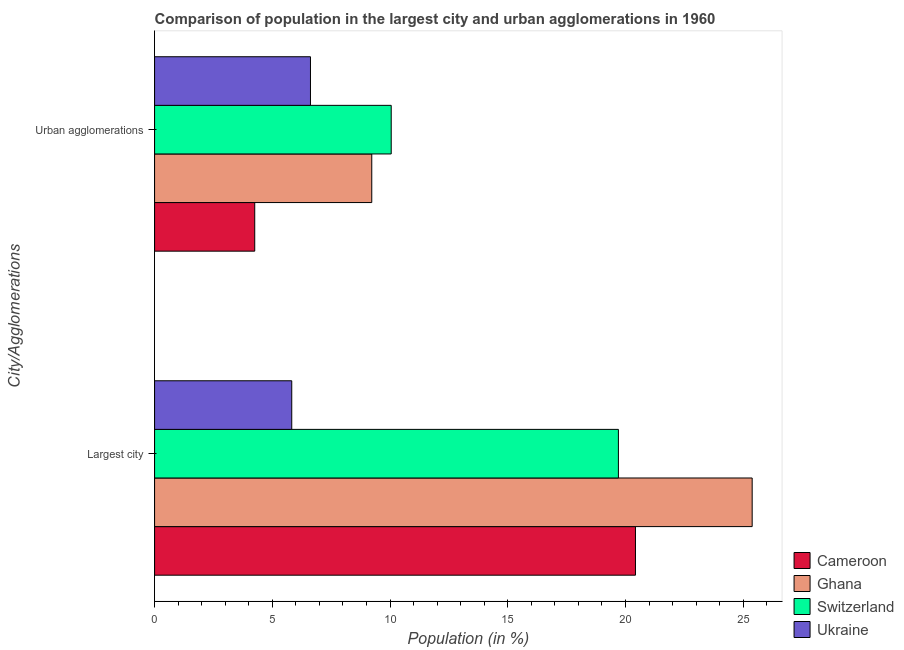How many groups of bars are there?
Make the answer very short. 2. Are the number of bars on each tick of the Y-axis equal?
Keep it short and to the point. Yes. What is the label of the 1st group of bars from the top?
Offer a terse response. Urban agglomerations. What is the population in the largest city in Cameroon?
Provide a succinct answer. 20.42. Across all countries, what is the maximum population in the largest city?
Keep it short and to the point. 25.38. Across all countries, what is the minimum population in the largest city?
Give a very brief answer. 5.83. In which country was the population in urban agglomerations maximum?
Provide a succinct answer. Switzerland. In which country was the population in the largest city minimum?
Give a very brief answer. Ukraine. What is the total population in the largest city in the graph?
Provide a succinct answer. 71.33. What is the difference between the population in the largest city in Ghana and that in Switzerland?
Offer a terse response. 5.68. What is the difference between the population in the largest city in Switzerland and the population in urban agglomerations in Cameroon?
Keep it short and to the point. 15.45. What is the average population in the largest city per country?
Make the answer very short. 17.83. What is the difference between the population in urban agglomerations and population in the largest city in Ghana?
Offer a very short reply. -16.16. In how many countries, is the population in the largest city greater than 7 %?
Offer a terse response. 3. What is the ratio of the population in urban agglomerations in Ukraine to that in Ghana?
Your answer should be very brief. 0.72. What does the 2nd bar from the top in Largest city represents?
Your answer should be compact. Switzerland. What does the 3rd bar from the bottom in Urban agglomerations represents?
Offer a very short reply. Switzerland. How many bars are there?
Your response must be concise. 8. Are all the bars in the graph horizontal?
Your answer should be compact. Yes. What is the difference between two consecutive major ticks on the X-axis?
Provide a succinct answer. 5. Are the values on the major ticks of X-axis written in scientific E-notation?
Give a very brief answer. No. Does the graph contain any zero values?
Ensure brevity in your answer.  No. Does the graph contain grids?
Your response must be concise. No. How many legend labels are there?
Give a very brief answer. 4. How are the legend labels stacked?
Make the answer very short. Vertical. What is the title of the graph?
Make the answer very short. Comparison of population in the largest city and urban agglomerations in 1960. Does "El Salvador" appear as one of the legend labels in the graph?
Your answer should be very brief. No. What is the label or title of the Y-axis?
Provide a short and direct response. City/Agglomerations. What is the Population (in %) in Cameroon in Largest city?
Your answer should be very brief. 20.42. What is the Population (in %) in Ghana in Largest city?
Provide a short and direct response. 25.38. What is the Population (in %) in Switzerland in Largest city?
Your response must be concise. 19.7. What is the Population (in %) of Ukraine in Largest city?
Give a very brief answer. 5.83. What is the Population (in %) in Cameroon in Urban agglomerations?
Your answer should be compact. 4.25. What is the Population (in %) in Ghana in Urban agglomerations?
Your answer should be compact. 9.22. What is the Population (in %) in Switzerland in Urban agglomerations?
Your answer should be very brief. 10.05. What is the Population (in %) in Ukraine in Urban agglomerations?
Offer a terse response. 6.62. Across all City/Agglomerations, what is the maximum Population (in %) of Cameroon?
Your response must be concise. 20.42. Across all City/Agglomerations, what is the maximum Population (in %) in Ghana?
Provide a succinct answer. 25.38. Across all City/Agglomerations, what is the maximum Population (in %) in Switzerland?
Ensure brevity in your answer.  19.7. Across all City/Agglomerations, what is the maximum Population (in %) in Ukraine?
Your answer should be very brief. 6.62. Across all City/Agglomerations, what is the minimum Population (in %) in Cameroon?
Keep it short and to the point. 4.25. Across all City/Agglomerations, what is the minimum Population (in %) in Ghana?
Your response must be concise. 9.22. Across all City/Agglomerations, what is the minimum Population (in %) of Switzerland?
Your response must be concise. 10.05. Across all City/Agglomerations, what is the minimum Population (in %) of Ukraine?
Your response must be concise. 5.83. What is the total Population (in %) of Cameroon in the graph?
Keep it short and to the point. 24.68. What is the total Population (in %) of Ghana in the graph?
Your response must be concise. 34.6. What is the total Population (in %) in Switzerland in the graph?
Offer a very short reply. 29.75. What is the total Population (in %) in Ukraine in the graph?
Your response must be concise. 12.45. What is the difference between the Population (in %) in Cameroon in Largest city and that in Urban agglomerations?
Provide a succinct answer. 16.17. What is the difference between the Population (in %) in Ghana in Largest city and that in Urban agglomerations?
Ensure brevity in your answer.  16.16. What is the difference between the Population (in %) of Switzerland in Largest city and that in Urban agglomerations?
Your answer should be compact. 9.65. What is the difference between the Population (in %) in Ukraine in Largest city and that in Urban agglomerations?
Make the answer very short. -0.79. What is the difference between the Population (in %) in Cameroon in Largest city and the Population (in %) in Ghana in Urban agglomerations?
Provide a succinct answer. 11.2. What is the difference between the Population (in %) in Cameroon in Largest city and the Population (in %) in Switzerland in Urban agglomerations?
Your response must be concise. 10.37. What is the difference between the Population (in %) in Cameroon in Largest city and the Population (in %) in Ukraine in Urban agglomerations?
Give a very brief answer. 13.8. What is the difference between the Population (in %) in Ghana in Largest city and the Population (in %) in Switzerland in Urban agglomerations?
Your response must be concise. 15.33. What is the difference between the Population (in %) of Ghana in Largest city and the Population (in %) of Ukraine in Urban agglomerations?
Offer a terse response. 18.76. What is the difference between the Population (in %) of Switzerland in Largest city and the Population (in %) of Ukraine in Urban agglomerations?
Provide a short and direct response. 13.08. What is the average Population (in %) in Cameroon per City/Agglomerations?
Ensure brevity in your answer.  12.34. What is the average Population (in %) in Ghana per City/Agglomerations?
Keep it short and to the point. 17.3. What is the average Population (in %) of Switzerland per City/Agglomerations?
Give a very brief answer. 14.87. What is the average Population (in %) of Ukraine per City/Agglomerations?
Provide a short and direct response. 6.22. What is the difference between the Population (in %) of Cameroon and Population (in %) of Ghana in Largest city?
Keep it short and to the point. -4.96. What is the difference between the Population (in %) in Cameroon and Population (in %) in Switzerland in Largest city?
Make the answer very short. 0.72. What is the difference between the Population (in %) in Cameroon and Population (in %) in Ukraine in Largest city?
Your answer should be compact. 14.6. What is the difference between the Population (in %) in Ghana and Population (in %) in Switzerland in Largest city?
Your answer should be compact. 5.68. What is the difference between the Population (in %) of Ghana and Population (in %) of Ukraine in Largest city?
Your answer should be very brief. 19.55. What is the difference between the Population (in %) of Switzerland and Population (in %) of Ukraine in Largest city?
Ensure brevity in your answer.  13.87. What is the difference between the Population (in %) of Cameroon and Population (in %) of Ghana in Urban agglomerations?
Offer a terse response. -4.97. What is the difference between the Population (in %) in Cameroon and Population (in %) in Switzerland in Urban agglomerations?
Provide a short and direct response. -5.8. What is the difference between the Population (in %) in Cameroon and Population (in %) in Ukraine in Urban agglomerations?
Your answer should be very brief. -2.37. What is the difference between the Population (in %) of Ghana and Population (in %) of Switzerland in Urban agglomerations?
Your answer should be very brief. -0.83. What is the difference between the Population (in %) of Ghana and Population (in %) of Ukraine in Urban agglomerations?
Your response must be concise. 2.6. What is the difference between the Population (in %) in Switzerland and Population (in %) in Ukraine in Urban agglomerations?
Provide a short and direct response. 3.43. What is the ratio of the Population (in %) in Cameroon in Largest city to that in Urban agglomerations?
Ensure brevity in your answer.  4.8. What is the ratio of the Population (in %) of Ghana in Largest city to that in Urban agglomerations?
Give a very brief answer. 2.75. What is the ratio of the Population (in %) in Switzerland in Largest city to that in Urban agglomerations?
Provide a short and direct response. 1.96. What is the ratio of the Population (in %) of Ukraine in Largest city to that in Urban agglomerations?
Offer a very short reply. 0.88. What is the difference between the highest and the second highest Population (in %) in Cameroon?
Provide a short and direct response. 16.17. What is the difference between the highest and the second highest Population (in %) in Ghana?
Give a very brief answer. 16.16. What is the difference between the highest and the second highest Population (in %) of Switzerland?
Your answer should be compact. 9.65. What is the difference between the highest and the second highest Population (in %) in Ukraine?
Offer a very short reply. 0.79. What is the difference between the highest and the lowest Population (in %) of Cameroon?
Provide a short and direct response. 16.17. What is the difference between the highest and the lowest Population (in %) of Ghana?
Ensure brevity in your answer.  16.16. What is the difference between the highest and the lowest Population (in %) of Switzerland?
Give a very brief answer. 9.65. What is the difference between the highest and the lowest Population (in %) of Ukraine?
Keep it short and to the point. 0.79. 